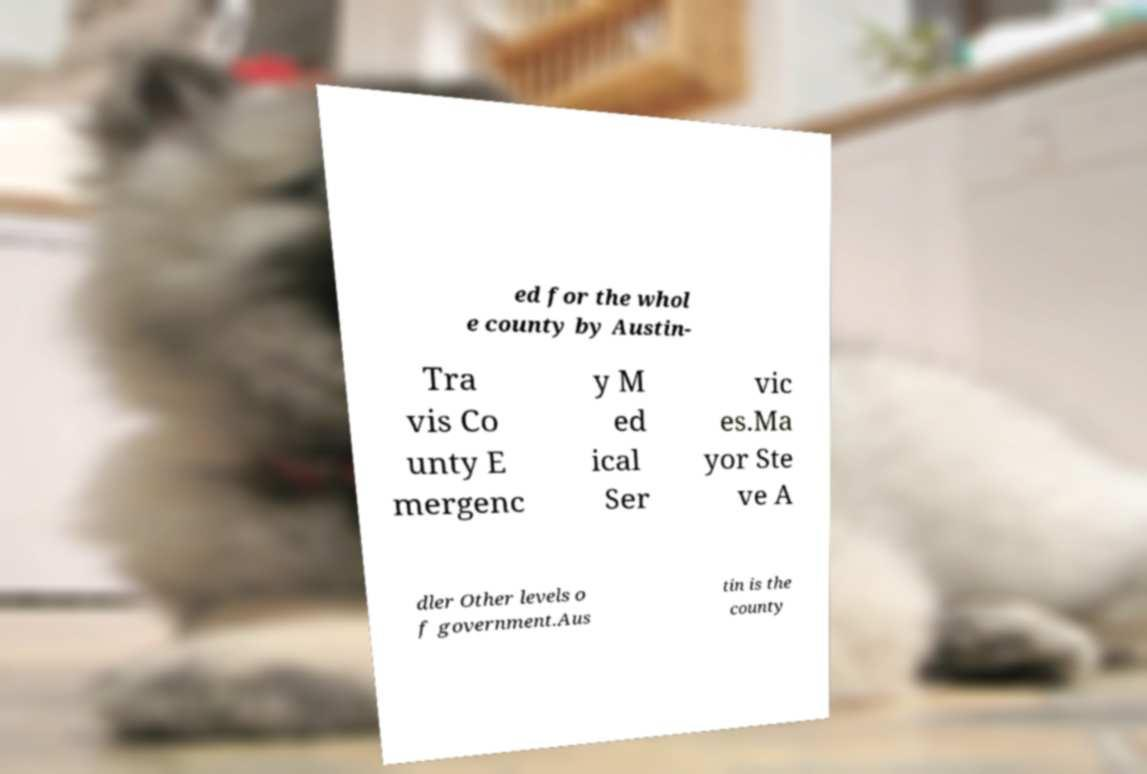For documentation purposes, I need the text within this image transcribed. Could you provide that? ed for the whol e county by Austin- Tra vis Co unty E mergenc y M ed ical Ser vic es.Ma yor Ste ve A dler Other levels o f government.Aus tin is the county 